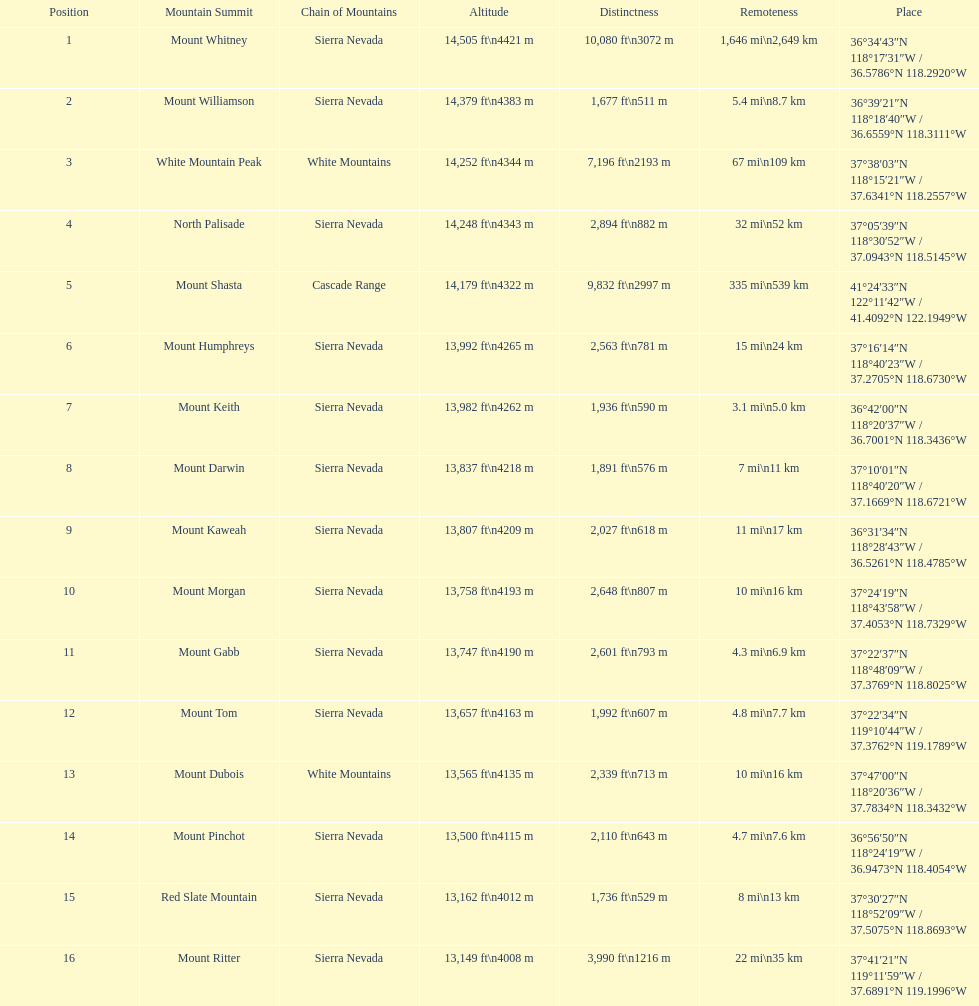Which is taller, mount humphreys or mount kaweah. Mount Humphreys. 